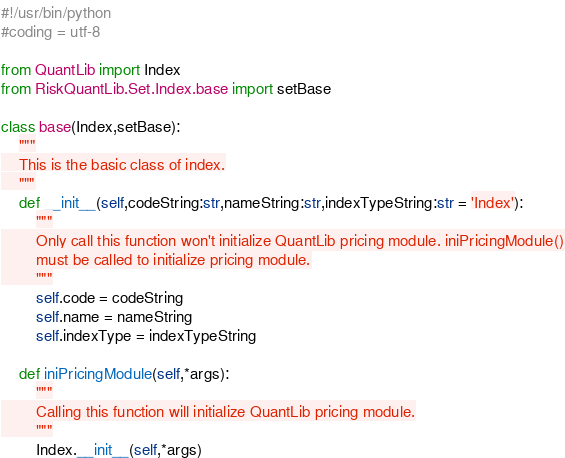<code> <loc_0><loc_0><loc_500><loc_500><_Python_>#!/usr/bin/python
#coding = utf-8

from QuantLib import Index
from RiskQuantLib.Set.Index.base import setBase

class base(Index,setBase):
    """
    This is the basic class of index.
    """
    def __init__(self,codeString:str,nameString:str,indexTypeString:str = 'Index'):
        """
        Only call this function won't initialize QuantLib pricing module. iniPricingModule()
        must be called to initialize pricing module.
        """
        self.code = codeString
        self.name = nameString
        self.indexType = indexTypeString

    def iniPricingModule(self,*args):
        """
        Calling this function will initialize QuantLib pricing module.
        """
        Index.__init__(self,*args)














</code> 